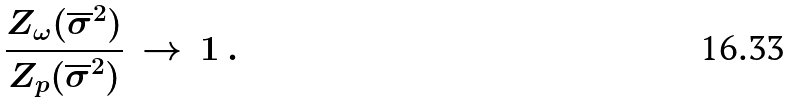<formula> <loc_0><loc_0><loc_500><loc_500>\frac { Z _ { \omega } ( \overline { \sigma } ^ { 2 } ) } { Z _ { p } ( \overline { \sigma } ^ { 2 } ) } \, \rightarrow \, 1 \, .</formula> 